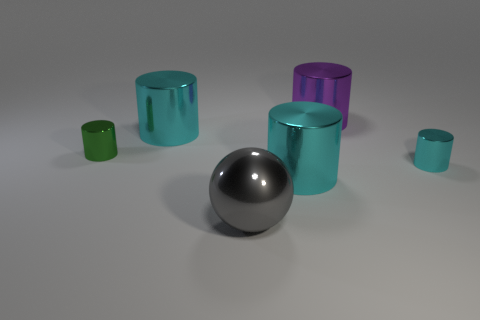There is a gray object in front of the small metal object that is on the left side of the big purple thing; what is its shape?
Keep it short and to the point. Sphere. How many things are either cylinders that are right of the small green metallic cylinder or cyan cylinders that are left of the gray metallic ball?
Make the answer very short. 4. There is a gray sphere that is the same size as the purple thing; what is it made of?
Keep it short and to the point. Metal. What color is the large ball?
Provide a short and direct response. Gray. There is a big cylinder that is behind the green metallic cylinder and in front of the purple metallic object; what is its material?
Provide a short and direct response. Metal. There is a small object that is on the right side of the big cyan thing that is in front of the tiny cyan metallic cylinder; are there any objects behind it?
Ensure brevity in your answer.  Yes. Are there any metallic things to the left of the small cyan cylinder?
Provide a short and direct response. Yes. What number of other objects are the same shape as the large gray object?
Make the answer very short. 0. There is a metallic object that is the same size as the green shiny cylinder; what is its color?
Provide a short and direct response. Cyan. Are there fewer cyan metal cylinders on the right side of the large gray sphere than shiny cylinders on the right side of the green metal cylinder?
Keep it short and to the point. Yes. 